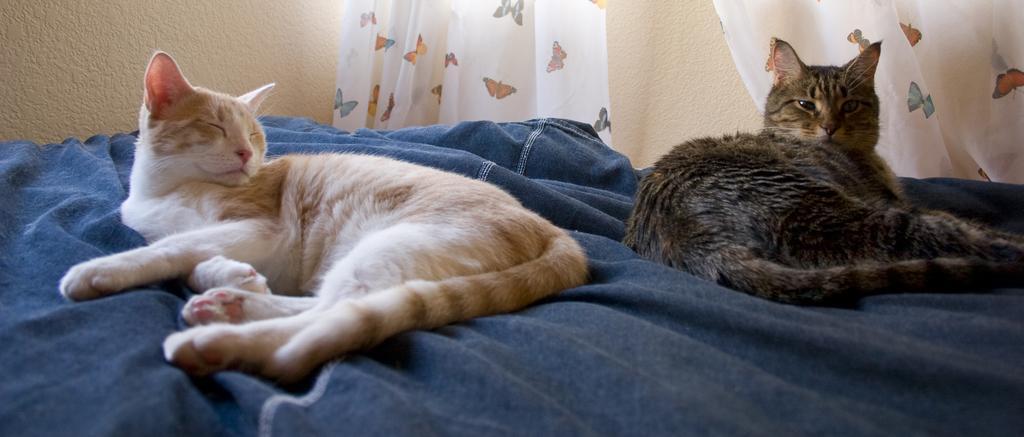How would you summarize this image in a sentence or two? In this image we can see few cats lying on the bed. There are few curtains in the image. 